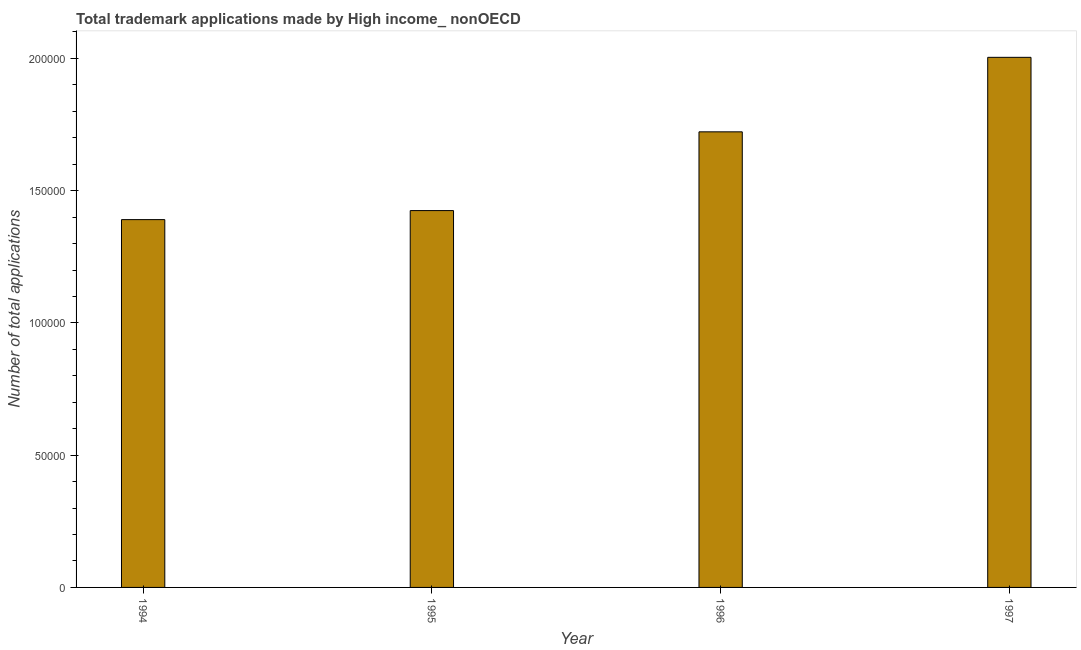Does the graph contain any zero values?
Offer a terse response. No. Does the graph contain grids?
Give a very brief answer. No. What is the title of the graph?
Ensure brevity in your answer.  Total trademark applications made by High income_ nonOECD. What is the label or title of the Y-axis?
Provide a short and direct response. Number of total applications. What is the number of trademark applications in 1996?
Offer a terse response. 1.72e+05. Across all years, what is the maximum number of trademark applications?
Offer a terse response. 2.00e+05. Across all years, what is the minimum number of trademark applications?
Your response must be concise. 1.39e+05. What is the sum of the number of trademark applications?
Keep it short and to the point. 6.54e+05. What is the difference between the number of trademark applications in 1994 and 1995?
Provide a succinct answer. -3413. What is the average number of trademark applications per year?
Offer a terse response. 1.64e+05. What is the median number of trademark applications?
Ensure brevity in your answer.  1.57e+05. What is the ratio of the number of trademark applications in 1996 to that in 1997?
Give a very brief answer. 0.86. What is the difference between the highest and the second highest number of trademark applications?
Ensure brevity in your answer.  2.82e+04. Is the sum of the number of trademark applications in 1996 and 1997 greater than the maximum number of trademark applications across all years?
Offer a very short reply. Yes. What is the difference between the highest and the lowest number of trademark applications?
Provide a short and direct response. 6.14e+04. Are all the bars in the graph horizontal?
Make the answer very short. No. What is the difference between two consecutive major ticks on the Y-axis?
Ensure brevity in your answer.  5.00e+04. Are the values on the major ticks of Y-axis written in scientific E-notation?
Your answer should be compact. No. What is the Number of total applications of 1994?
Your answer should be very brief. 1.39e+05. What is the Number of total applications in 1995?
Make the answer very short. 1.42e+05. What is the Number of total applications in 1996?
Offer a very short reply. 1.72e+05. What is the Number of total applications in 1997?
Provide a succinct answer. 2.00e+05. What is the difference between the Number of total applications in 1994 and 1995?
Keep it short and to the point. -3413. What is the difference between the Number of total applications in 1994 and 1996?
Provide a succinct answer. -3.32e+04. What is the difference between the Number of total applications in 1994 and 1997?
Keep it short and to the point. -6.14e+04. What is the difference between the Number of total applications in 1995 and 1996?
Ensure brevity in your answer.  -2.98e+04. What is the difference between the Number of total applications in 1995 and 1997?
Offer a very short reply. -5.79e+04. What is the difference between the Number of total applications in 1996 and 1997?
Offer a terse response. -2.82e+04. What is the ratio of the Number of total applications in 1994 to that in 1995?
Offer a very short reply. 0.98. What is the ratio of the Number of total applications in 1994 to that in 1996?
Your response must be concise. 0.81. What is the ratio of the Number of total applications in 1994 to that in 1997?
Keep it short and to the point. 0.69. What is the ratio of the Number of total applications in 1995 to that in 1996?
Offer a terse response. 0.83. What is the ratio of the Number of total applications in 1995 to that in 1997?
Your response must be concise. 0.71. What is the ratio of the Number of total applications in 1996 to that in 1997?
Offer a terse response. 0.86. 